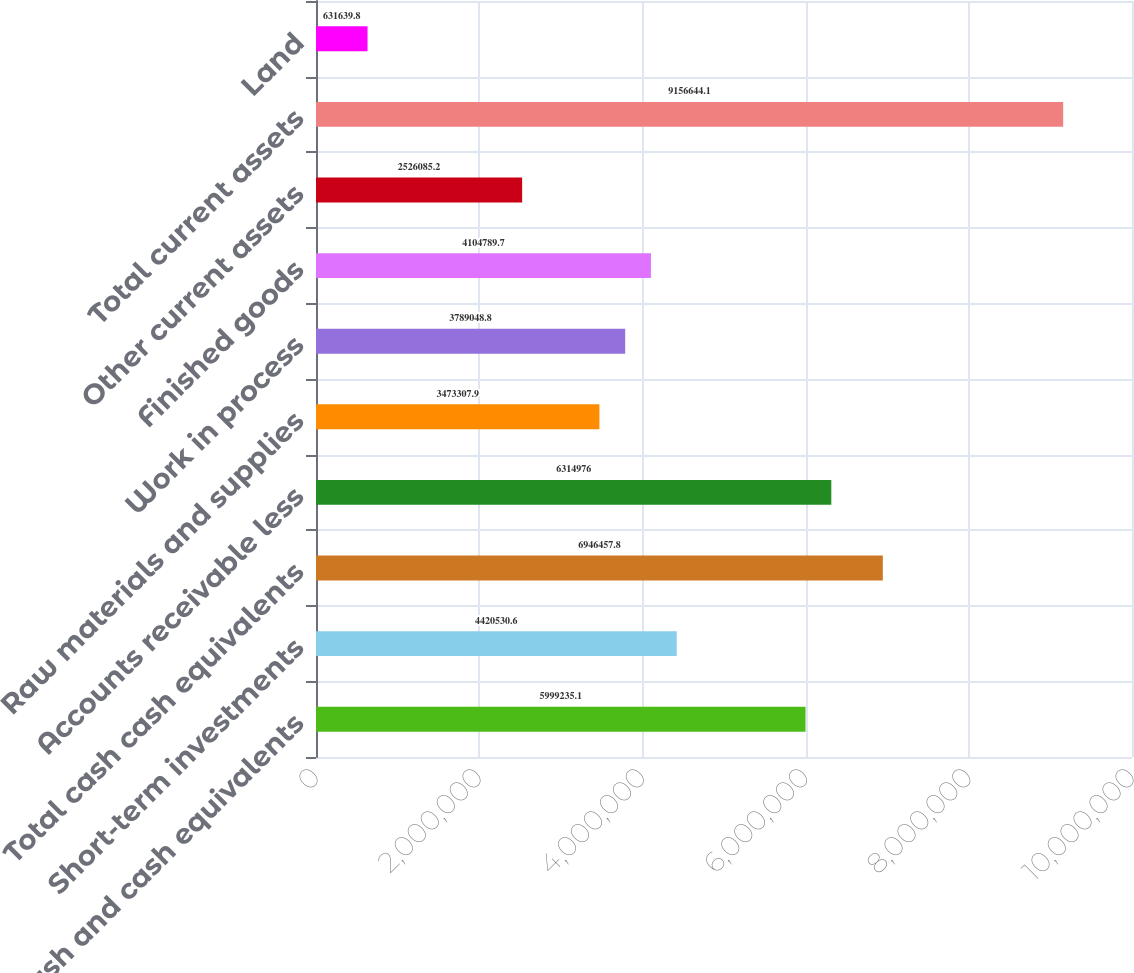Convert chart. <chart><loc_0><loc_0><loc_500><loc_500><bar_chart><fcel>Cash and cash equivalents<fcel>Short-term investments<fcel>Total cash cash equivalents<fcel>Accounts receivable less<fcel>Raw materials and supplies<fcel>Work in process<fcel>Finished goods<fcel>Other current assets<fcel>Total current assets<fcel>Land<nl><fcel>5.99924e+06<fcel>4.42053e+06<fcel>6.94646e+06<fcel>6.31498e+06<fcel>3.47331e+06<fcel>3.78905e+06<fcel>4.10479e+06<fcel>2.52609e+06<fcel>9.15664e+06<fcel>631640<nl></chart> 